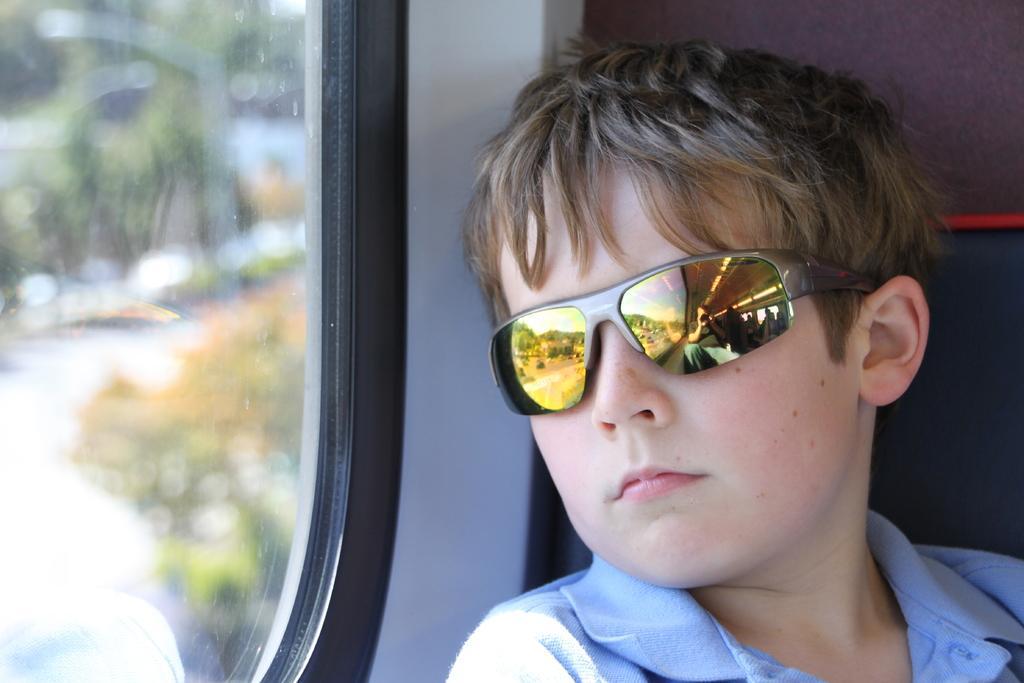How would you summarize this image in a sentence or two? In the picture we can see a boy sitting in the vehicle and beside the boy we can see a glass window from it, we can see some plants which are not clearly visible and boy is wearing a blue shirt and goggles and he is looking towards the window. 